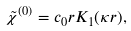<formula> <loc_0><loc_0><loc_500><loc_500>\tilde { \chi } ^ { ( 0 ) } = c _ { 0 } r K _ { 1 } ( \kappa r ) ,</formula> 